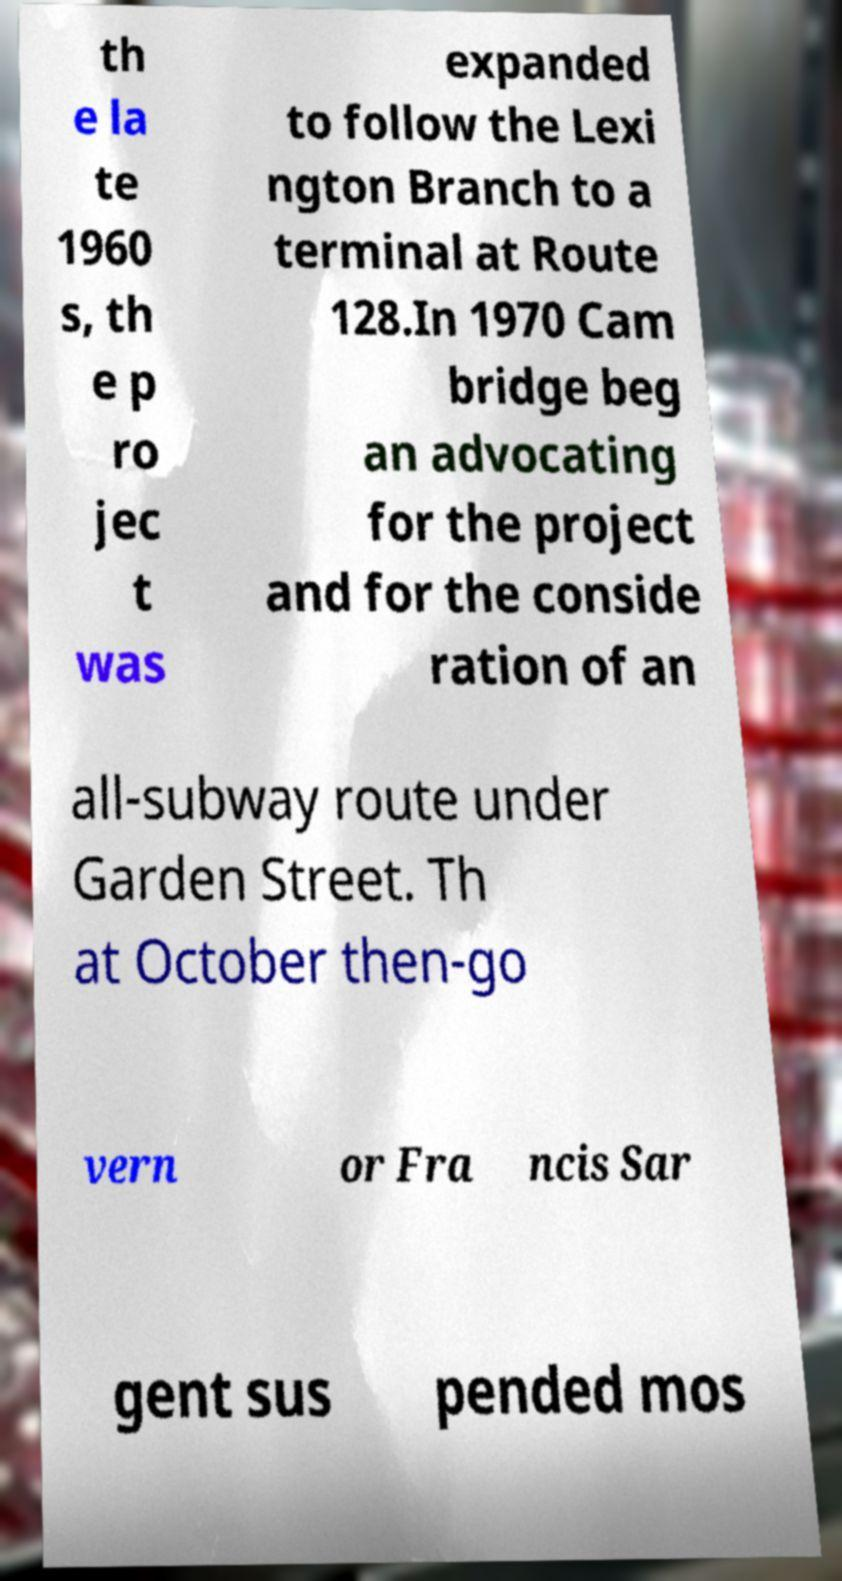Could you extract and type out the text from this image? th e la te 1960 s, th e p ro jec t was expanded to follow the Lexi ngton Branch to a terminal at Route 128.In 1970 Cam bridge beg an advocating for the project and for the conside ration of an all-subway route under Garden Street. Th at October then-go vern or Fra ncis Sar gent sus pended mos 